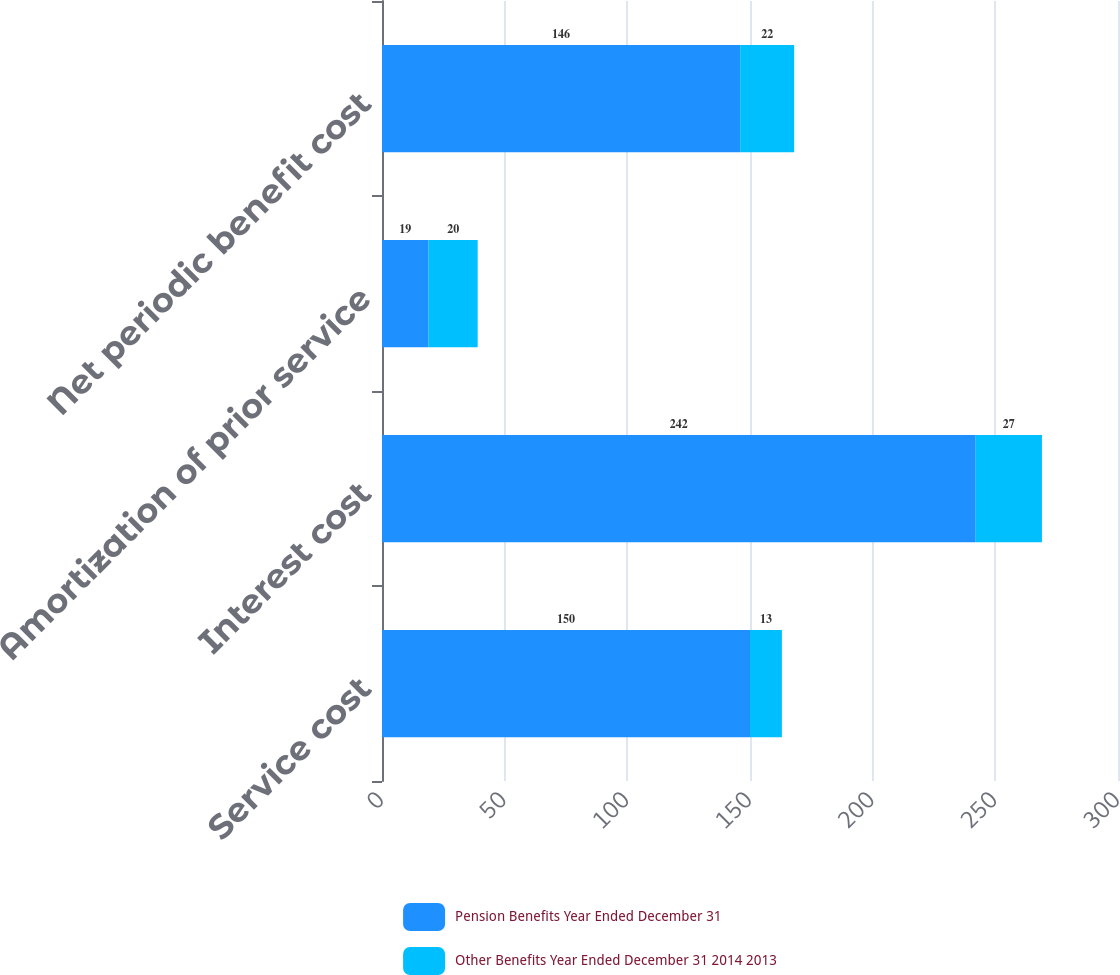Convert chart. <chart><loc_0><loc_0><loc_500><loc_500><stacked_bar_chart><ecel><fcel>Service cost<fcel>Interest cost<fcel>Amortization of prior service<fcel>Net periodic benefit cost<nl><fcel>Pension Benefits Year Ended December 31<fcel>150<fcel>242<fcel>19<fcel>146<nl><fcel>Other Benefits Year Ended December 31 2014 2013<fcel>13<fcel>27<fcel>20<fcel>22<nl></chart> 